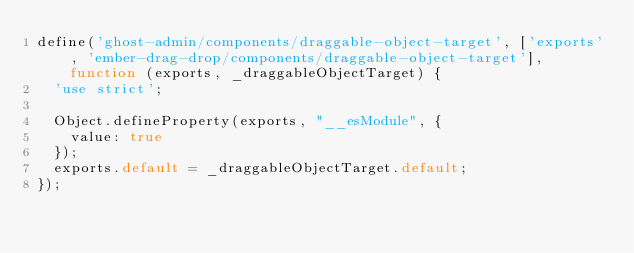Convert code to text. <code><loc_0><loc_0><loc_500><loc_500><_JavaScript_>define('ghost-admin/components/draggable-object-target', ['exports', 'ember-drag-drop/components/draggable-object-target'], function (exports, _draggableObjectTarget) {
  'use strict';

  Object.defineProperty(exports, "__esModule", {
    value: true
  });
  exports.default = _draggableObjectTarget.default;
});</code> 